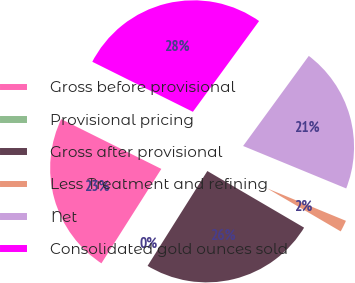Convert chart. <chart><loc_0><loc_0><loc_500><loc_500><pie_chart><fcel>Gross before provisional<fcel>Provisional pricing<fcel>Gross after provisional<fcel>Less Treatment and refining<fcel>Net<fcel>Consolidated gold ounces sold<nl><fcel>23.35%<fcel>0.05%<fcel>25.52%<fcel>2.21%<fcel>21.19%<fcel>27.68%<nl></chart> 